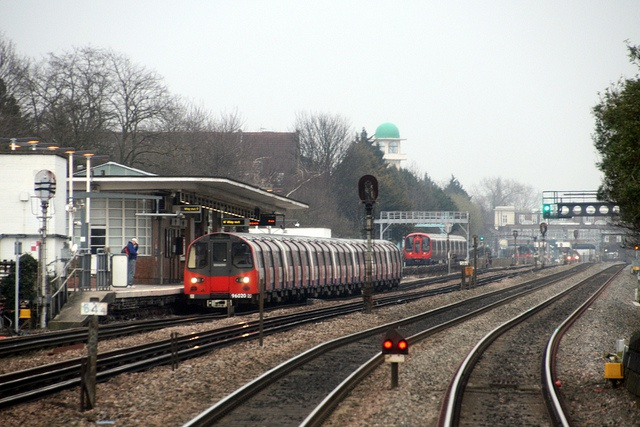Describe the objects in this image and their specific colors. I can see train in lightgray, black, gray, and darkgray tones, train in lightgray, gray, darkgray, and brown tones, people in lightgray, gray, navy, black, and darkgray tones, and backpack in lightgray, black, and purple tones in this image. 